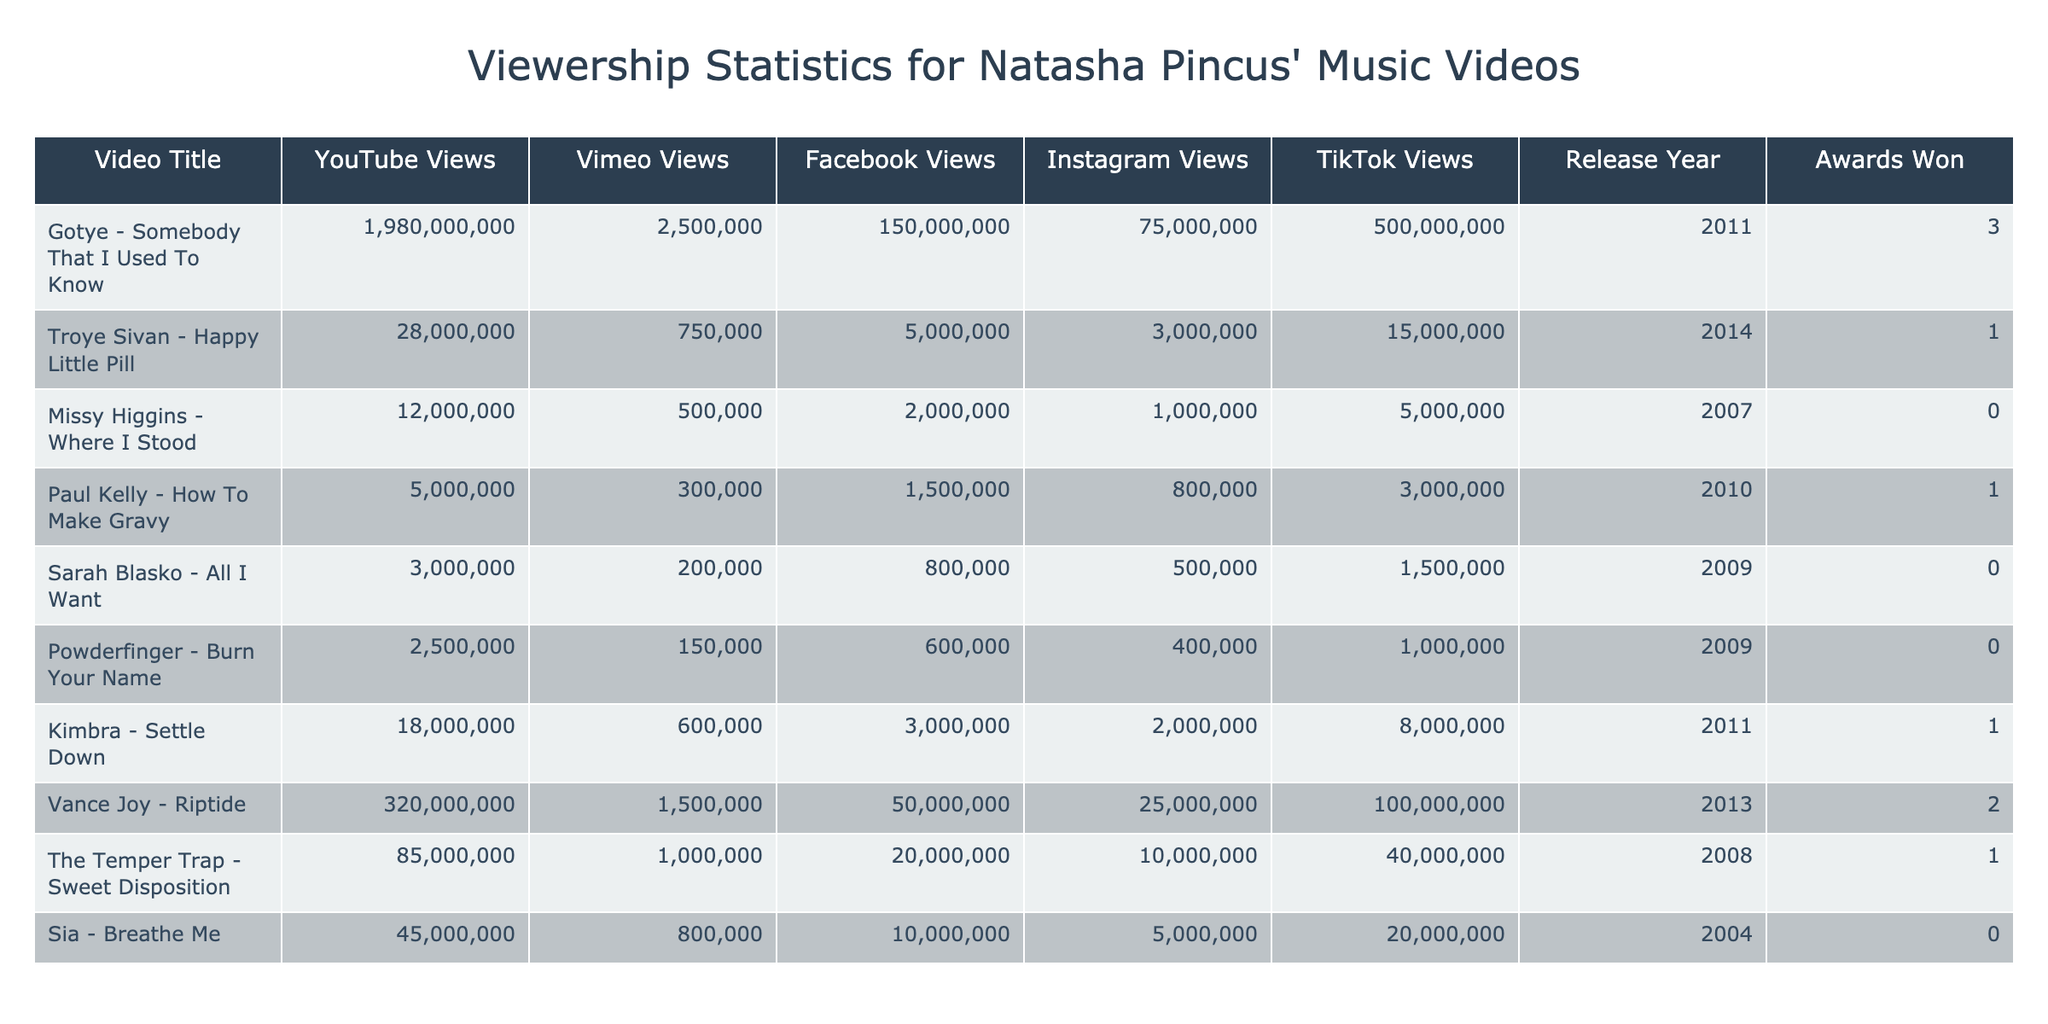What video has the highest number of views on YouTube? The table shows views for each video on YouTube, and the highest value is 1,980,000,000 for "Gotye - Somebody That I Used To Know".
Answer: Gotye - Somebody That I Used To Know How many total views did "Vance Joy - Riptide" receive across all platforms? Summing the views from all platforms for "Vance Joy - Riptide": 320,000,000 + 1,500,000 + 50,000,000 + 25,000,000 + 100,000,000 = 496,500,000.
Answer: 496,500,000 Did "Sarah Blasko - All I Want" win any awards? The table indicates an 'Awards Won' value of 0 for "Sarah Blasko - All I Want".
Answer: No Which video released in 2014 had the highest views on Facebook? For videos released in 2014, "Troye Sivan - Happy Little Pill" is the only one listed, with 5,000,000 Facebook views. No comparison is needed as it’s the only video from that year.
Answer: Troye Sivan - Happy Little Pill What is the difference in YouTube views between "Missy Higgins - Where I Stood" and "Kimbra - Settle Down"? "Missy Higgins - Where I Stood" has 12,000,000 YouTube views while "Kimbra - Settle Down" has 18,000,000. The difference is 18,000,000 - 12,000,000 = 6,000,000.
Answer: 6,000,000 Which video released between 2008 and 2013 has the highest total views? We calculate the total views for videos released between 2008 and 2013 (inclusive). "Vance Joy - Riptide" has 496,500,000 total views, which is higher than others like "The Temper Trap - Sweet Disposition" (85,000,000) and "Troye Sivan - Happy Little Pill" (28,000,000). Thus, "Vance Joy - Riptide" is the answer.
Answer: Vance Joy - Riptide How many videos won more than 2 awards? Inspecting the 'Awards Won' column, only "Gotye - Somebody That I Used To Know" has won awards (3 awards). Therefore, only one video has won more than 2 awards.
Answer: 1 What video had the least amount of views on Instagram? Looking at the Instagram views, "Sarah Blasko - All I Want" has 500,000 views, which is the lowest compared to others.
Answer: Sarah Blasko - All I Want 